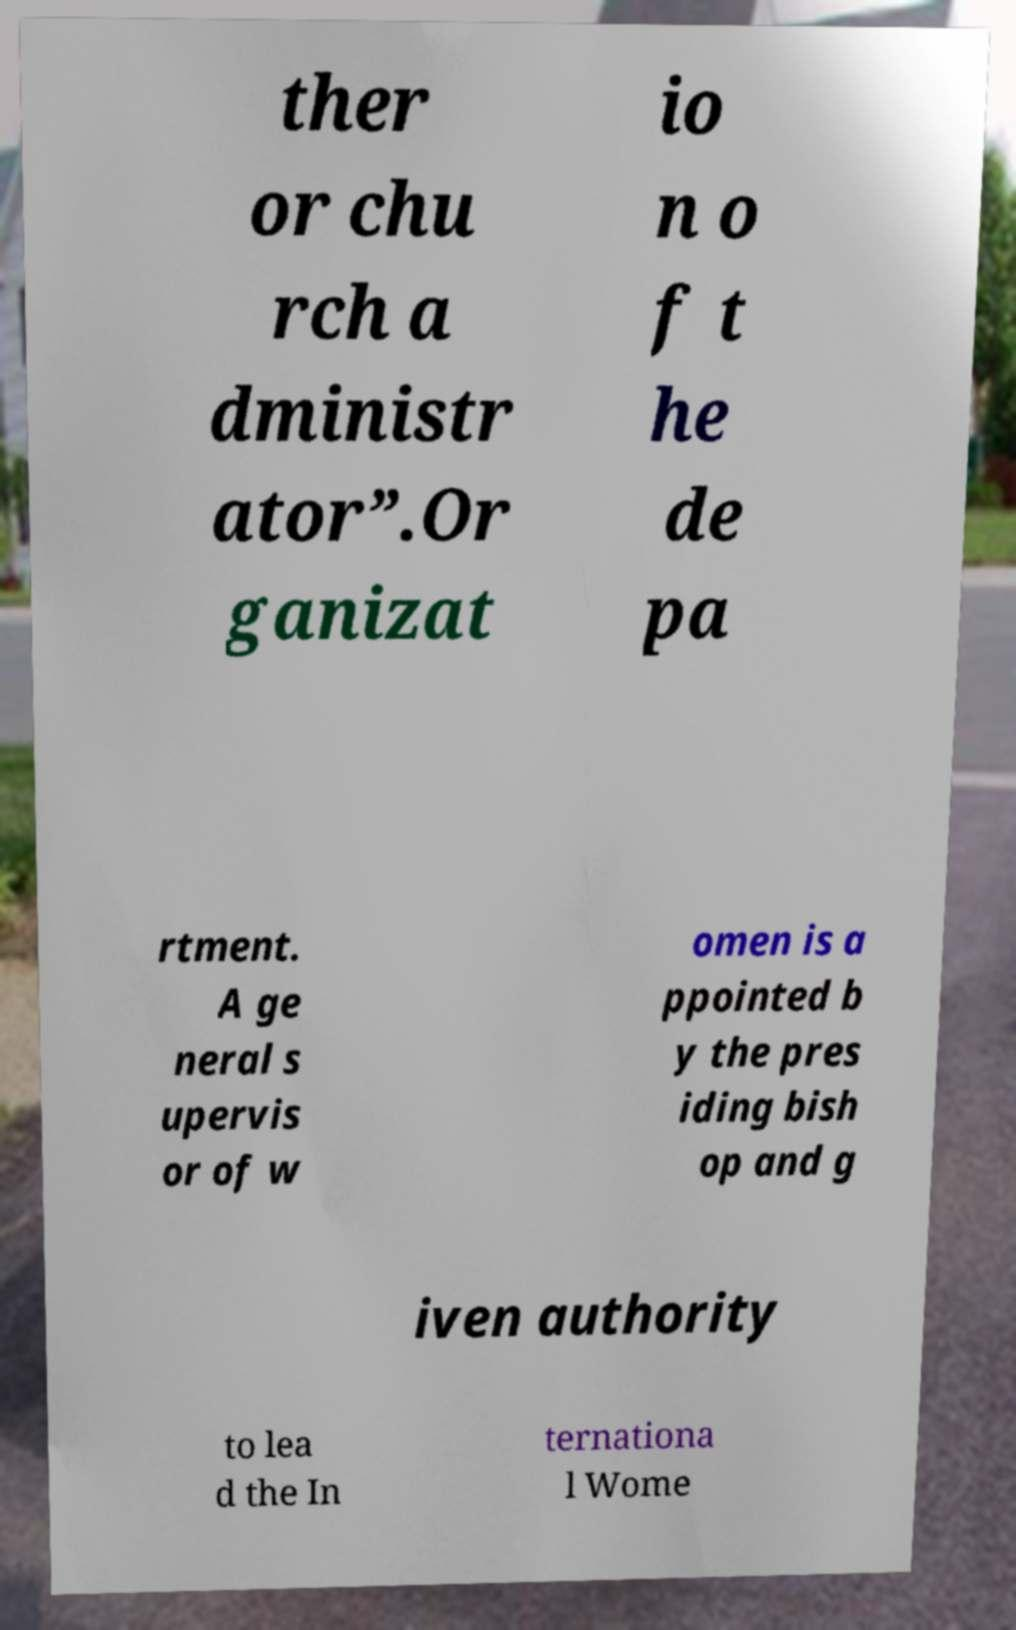Can you read and provide the text displayed in the image?This photo seems to have some interesting text. Can you extract and type it out for me? ther or chu rch a dministr ator”.Or ganizat io n o f t he de pa rtment. A ge neral s upervis or of w omen is a ppointed b y the pres iding bish op and g iven authority to lea d the In ternationa l Wome 